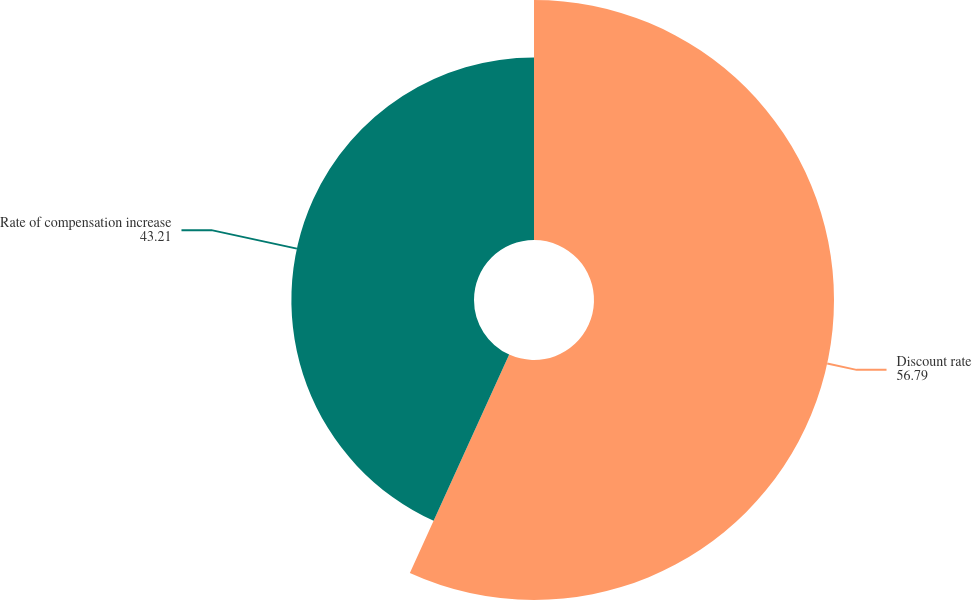<chart> <loc_0><loc_0><loc_500><loc_500><pie_chart><fcel>Discount rate<fcel>Rate of compensation increase<nl><fcel>56.79%<fcel>43.21%<nl></chart> 